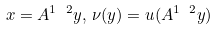<formula> <loc_0><loc_0><loc_500><loc_500>x = A ^ { 1 \ 2 } y , \, \nu ( y ) = u ( A ^ { 1 \ 2 } y )</formula> 